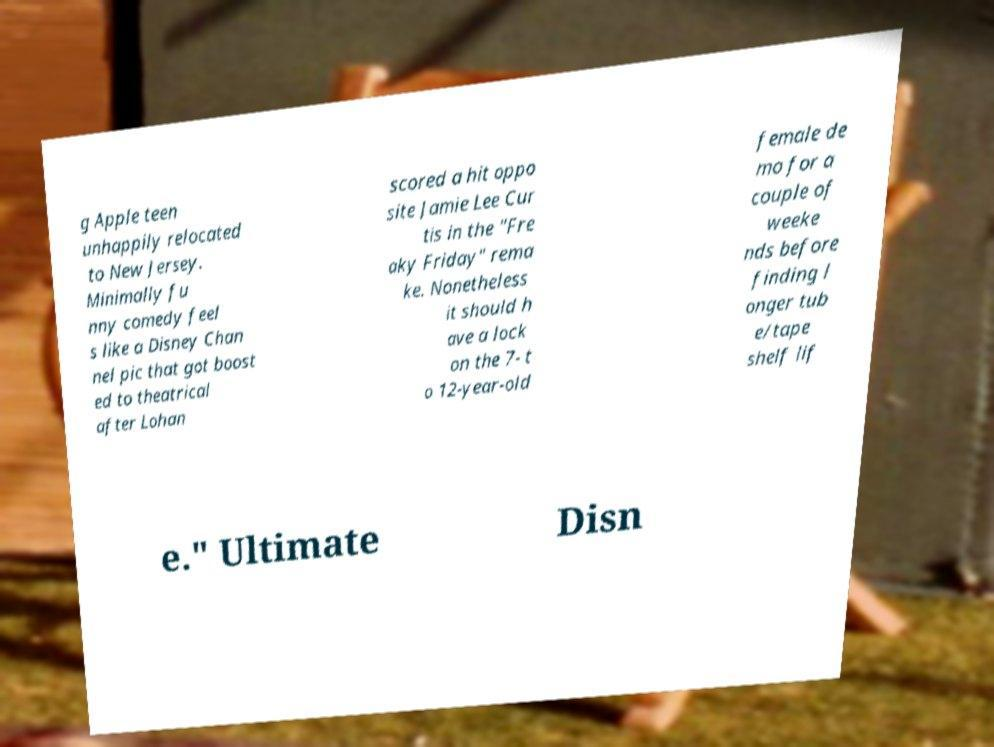Please identify and transcribe the text found in this image. g Apple teen unhappily relocated to New Jersey. Minimally fu nny comedy feel s like a Disney Chan nel pic that got boost ed to theatrical after Lohan scored a hit oppo site Jamie Lee Cur tis in the "Fre aky Friday" rema ke. Nonetheless it should h ave a lock on the 7- t o 12-year-old female de mo for a couple of weeke nds before finding l onger tub e/tape shelf lif e." Ultimate Disn 